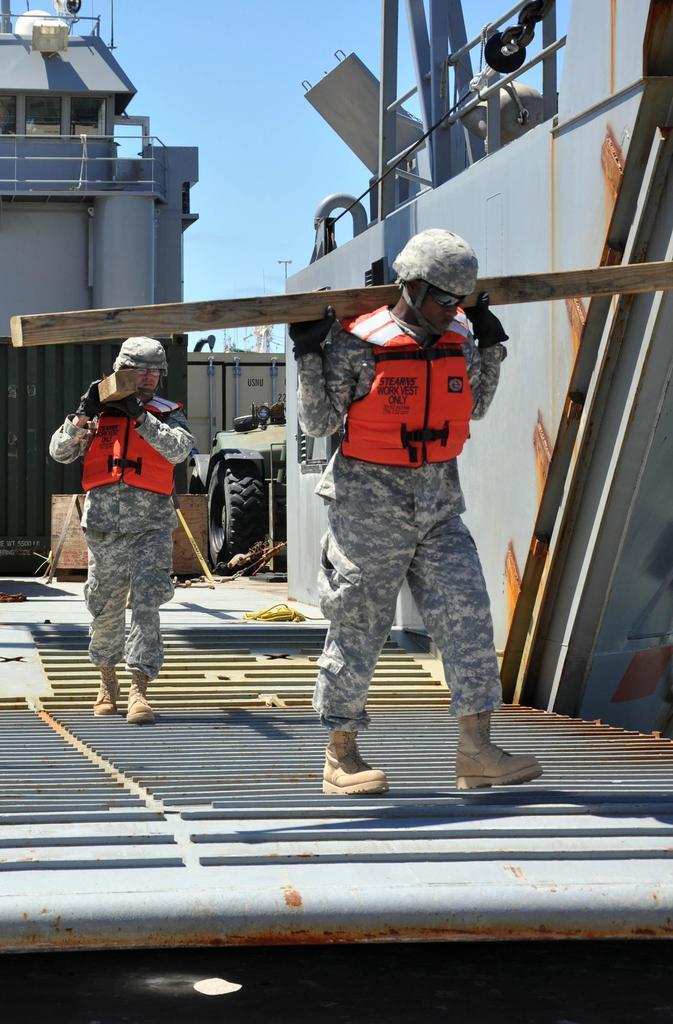Describe this image in one or two sentences. In this picture couple of men walking and holding wooden planks and it looks like a ship and I can see a blue sky. 